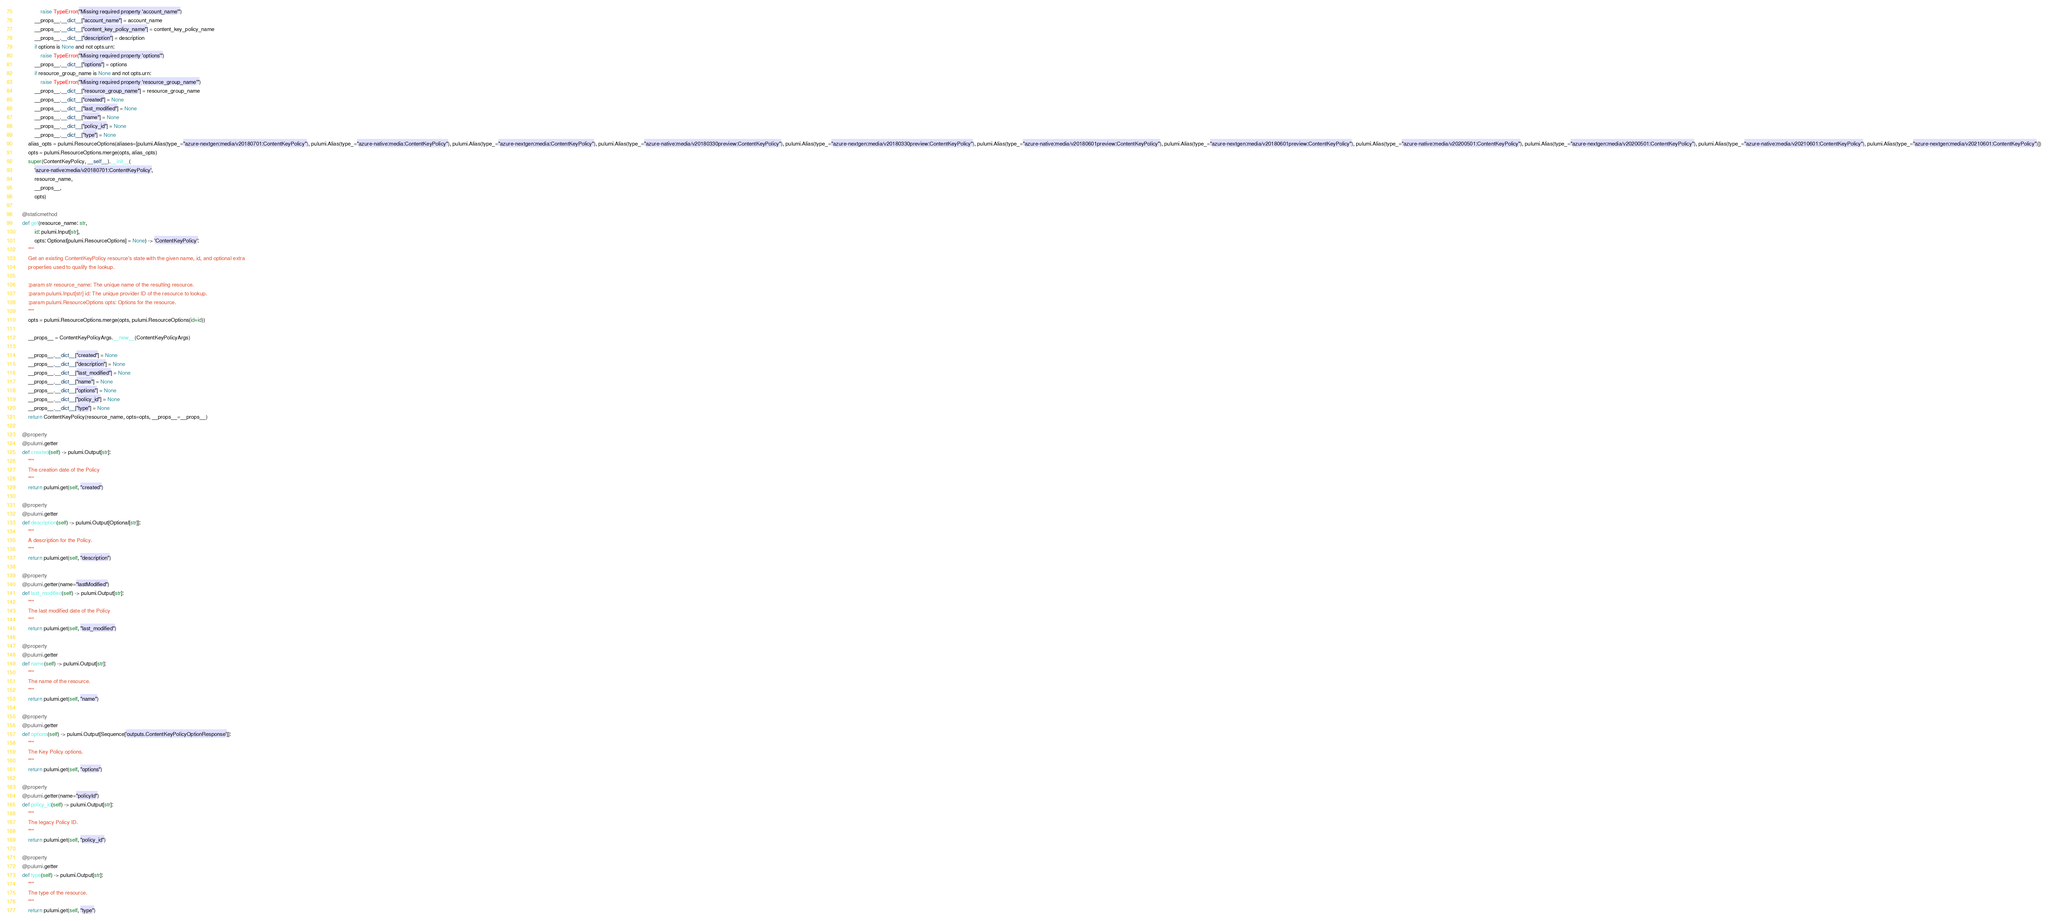Convert code to text. <code><loc_0><loc_0><loc_500><loc_500><_Python_>                raise TypeError("Missing required property 'account_name'")
            __props__.__dict__["account_name"] = account_name
            __props__.__dict__["content_key_policy_name"] = content_key_policy_name
            __props__.__dict__["description"] = description
            if options is None and not opts.urn:
                raise TypeError("Missing required property 'options'")
            __props__.__dict__["options"] = options
            if resource_group_name is None and not opts.urn:
                raise TypeError("Missing required property 'resource_group_name'")
            __props__.__dict__["resource_group_name"] = resource_group_name
            __props__.__dict__["created"] = None
            __props__.__dict__["last_modified"] = None
            __props__.__dict__["name"] = None
            __props__.__dict__["policy_id"] = None
            __props__.__dict__["type"] = None
        alias_opts = pulumi.ResourceOptions(aliases=[pulumi.Alias(type_="azure-nextgen:media/v20180701:ContentKeyPolicy"), pulumi.Alias(type_="azure-native:media:ContentKeyPolicy"), pulumi.Alias(type_="azure-nextgen:media:ContentKeyPolicy"), pulumi.Alias(type_="azure-native:media/v20180330preview:ContentKeyPolicy"), pulumi.Alias(type_="azure-nextgen:media/v20180330preview:ContentKeyPolicy"), pulumi.Alias(type_="azure-native:media/v20180601preview:ContentKeyPolicy"), pulumi.Alias(type_="azure-nextgen:media/v20180601preview:ContentKeyPolicy"), pulumi.Alias(type_="azure-native:media/v20200501:ContentKeyPolicy"), pulumi.Alias(type_="azure-nextgen:media/v20200501:ContentKeyPolicy"), pulumi.Alias(type_="azure-native:media/v20210601:ContentKeyPolicy"), pulumi.Alias(type_="azure-nextgen:media/v20210601:ContentKeyPolicy")])
        opts = pulumi.ResourceOptions.merge(opts, alias_opts)
        super(ContentKeyPolicy, __self__).__init__(
            'azure-native:media/v20180701:ContentKeyPolicy',
            resource_name,
            __props__,
            opts)

    @staticmethod
    def get(resource_name: str,
            id: pulumi.Input[str],
            opts: Optional[pulumi.ResourceOptions] = None) -> 'ContentKeyPolicy':
        """
        Get an existing ContentKeyPolicy resource's state with the given name, id, and optional extra
        properties used to qualify the lookup.

        :param str resource_name: The unique name of the resulting resource.
        :param pulumi.Input[str] id: The unique provider ID of the resource to lookup.
        :param pulumi.ResourceOptions opts: Options for the resource.
        """
        opts = pulumi.ResourceOptions.merge(opts, pulumi.ResourceOptions(id=id))

        __props__ = ContentKeyPolicyArgs.__new__(ContentKeyPolicyArgs)

        __props__.__dict__["created"] = None
        __props__.__dict__["description"] = None
        __props__.__dict__["last_modified"] = None
        __props__.__dict__["name"] = None
        __props__.__dict__["options"] = None
        __props__.__dict__["policy_id"] = None
        __props__.__dict__["type"] = None
        return ContentKeyPolicy(resource_name, opts=opts, __props__=__props__)

    @property
    @pulumi.getter
    def created(self) -> pulumi.Output[str]:
        """
        The creation date of the Policy
        """
        return pulumi.get(self, "created")

    @property
    @pulumi.getter
    def description(self) -> pulumi.Output[Optional[str]]:
        """
        A description for the Policy.
        """
        return pulumi.get(self, "description")

    @property
    @pulumi.getter(name="lastModified")
    def last_modified(self) -> pulumi.Output[str]:
        """
        The last modified date of the Policy
        """
        return pulumi.get(self, "last_modified")

    @property
    @pulumi.getter
    def name(self) -> pulumi.Output[str]:
        """
        The name of the resource.
        """
        return pulumi.get(self, "name")

    @property
    @pulumi.getter
    def options(self) -> pulumi.Output[Sequence['outputs.ContentKeyPolicyOptionResponse']]:
        """
        The Key Policy options.
        """
        return pulumi.get(self, "options")

    @property
    @pulumi.getter(name="policyId")
    def policy_id(self) -> pulumi.Output[str]:
        """
        The legacy Policy ID.
        """
        return pulumi.get(self, "policy_id")

    @property
    @pulumi.getter
    def type(self) -> pulumi.Output[str]:
        """
        The type of the resource.
        """
        return pulumi.get(self, "type")

</code> 